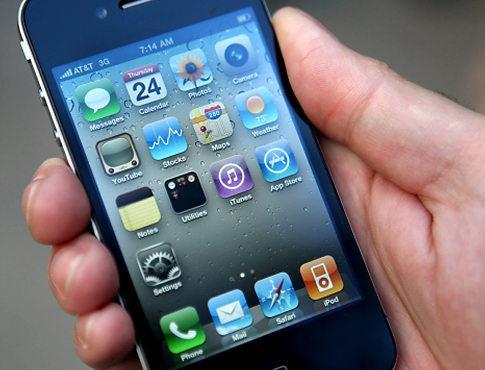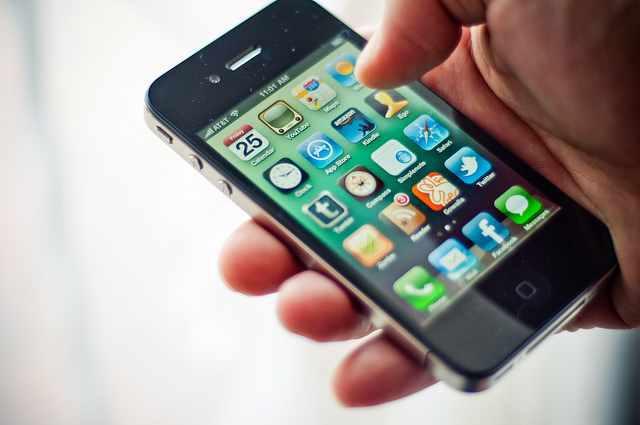The first image is the image on the left, the second image is the image on the right. Analyze the images presented: Is the assertion "The right image features a black phone held by a hand with the thumb on the right, and the left image contains at least one phone but no hand." valid? Answer yes or no. No. The first image is the image on the left, the second image is the image on the right. For the images displayed, is the sentence "A phone sits alone in the image on the left, while the phone in the image on the right is held." factually correct? Answer yes or no. No. 